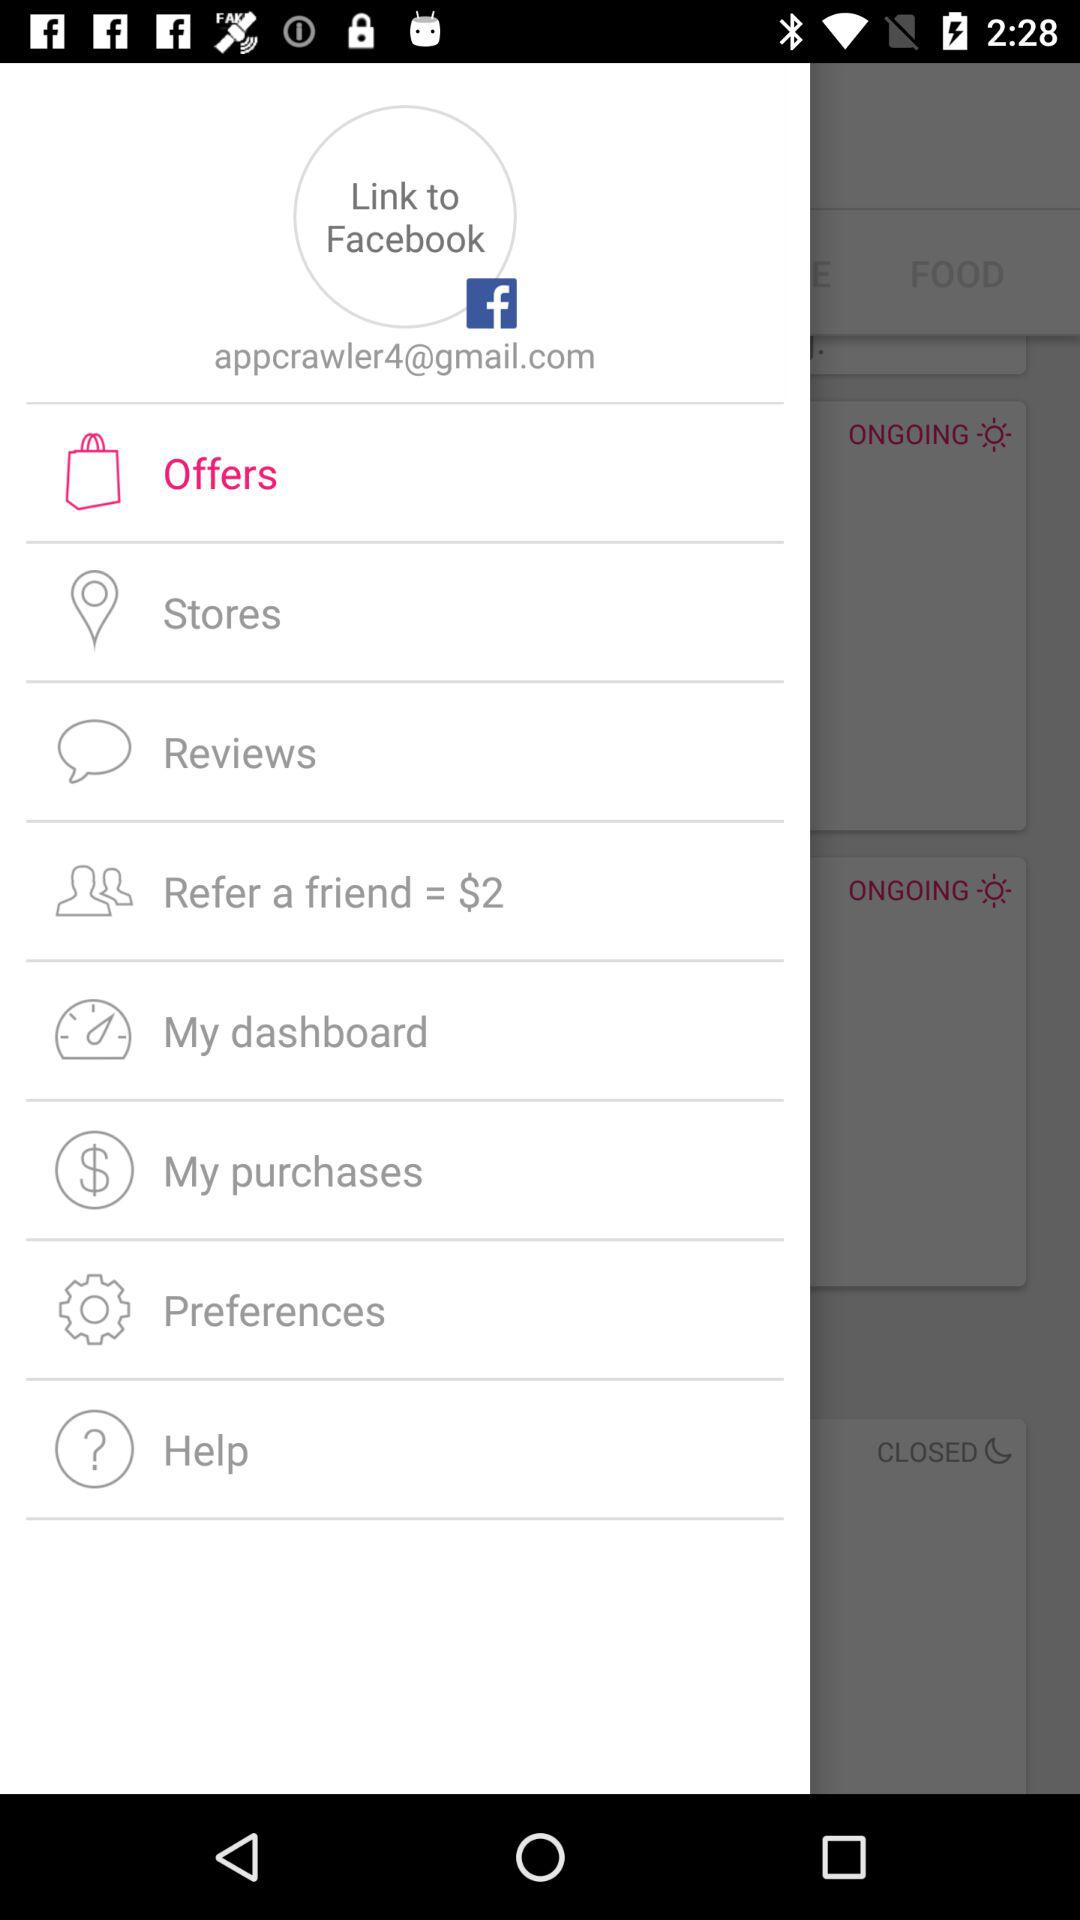Which option is highlighted? The highlighted option is "Offers". 